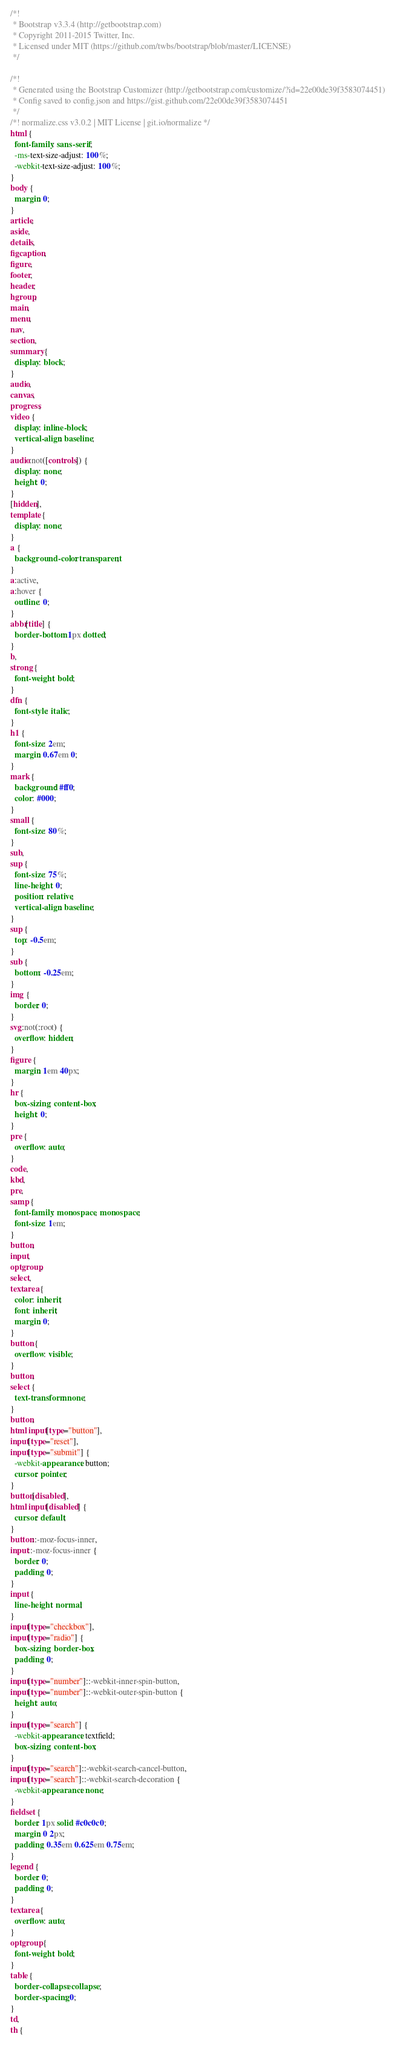<code> <loc_0><loc_0><loc_500><loc_500><_CSS_>/*!
 * Bootstrap v3.3.4 (http://getbootstrap.com)
 * Copyright 2011-2015 Twitter, Inc.
 * Licensed under MIT (https://github.com/twbs/bootstrap/blob/master/LICENSE)
 */

/*!
 * Generated using the Bootstrap Customizer (http://getbootstrap.com/customize/?id=22e00de39f3583074451)
 * Config saved to config.json and https://gist.github.com/22e00de39f3583074451
 */
/*! normalize.css v3.0.2 | MIT License | git.io/normalize */
html {
  font-family: sans-serif;
  -ms-text-size-adjust: 100%;
  -webkit-text-size-adjust: 100%;
}
body {
  margin: 0;
}
article,
aside,
details,
figcaption,
figure,
footer,
header,
hgroup,
main,
menu,
nav,
section,
summary {
  display: block;
}
audio,
canvas,
progress,
video {
  display: inline-block;
  vertical-align: baseline;
}
audio:not([controls]) {
  display: none;
  height: 0;
}
[hidden],
template {
  display: none;
}
a {
  background-color: transparent;
}
a:active,
a:hover {
  outline: 0;
}
abbr[title] {
  border-bottom: 1px dotted;
}
b,
strong {
  font-weight: bold;
}
dfn {
  font-style: italic;
}
h1 {
  font-size: 2em;
  margin: 0.67em 0;
}
mark {
  background: #ff0;
  color: #000;
}
small {
  font-size: 80%;
}
sub,
sup {
  font-size: 75%;
  line-height: 0;
  position: relative;
  vertical-align: baseline;
}
sup {
  top: -0.5em;
}
sub {
  bottom: -0.25em;
}
img {
  border: 0;
}
svg:not(:root) {
  overflow: hidden;
}
figure {
  margin: 1em 40px;
}
hr {
  box-sizing: content-box;
  height: 0;
}
pre {
  overflow: auto;
}
code,
kbd,
pre,
samp {
  font-family: monospace, monospace;
  font-size: 1em;
}
button,
input,
optgroup,
select,
textarea {
  color: inherit;
  font: inherit;
  margin: 0;
}
button {
  overflow: visible;
}
button,
select {
  text-transform: none;
}
button,
html input[type="button"],
input[type="reset"],
input[type="submit"] {
  -webkit-appearance: button;
  cursor: pointer;
}
button[disabled],
html input[disabled] {
  cursor: default;
}
button::-moz-focus-inner,
input::-moz-focus-inner {
  border: 0;
  padding: 0;
}
input {
  line-height: normal;
}
input[type="checkbox"],
input[type="radio"] {
  box-sizing: border-box;
  padding: 0;
}
input[type="number"]::-webkit-inner-spin-button,
input[type="number"]::-webkit-outer-spin-button {
  height: auto;
}
input[type="search"] {
  -webkit-appearance: textfield;
  box-sizing: content-box;
}
input[type="search"]::-webkit-search-cancel-button,
input[type="search"]::-webkit-search-decoration {
  -webkit-appearance: none;
}
fieldset {
  border: 1px solid #c0c0c0;
  margin: 0 2px;
  padding: 0.35em 0.625em 0.75em;
}
legend {
  border: 0;
  padding: 0;
}
textarea {
  overflow: auto;
}
optgroup {
  font-weight: bold;
}
table {
  border-collapse: collapse;
  border-spacing: 0;
}
td,
th {</code> 